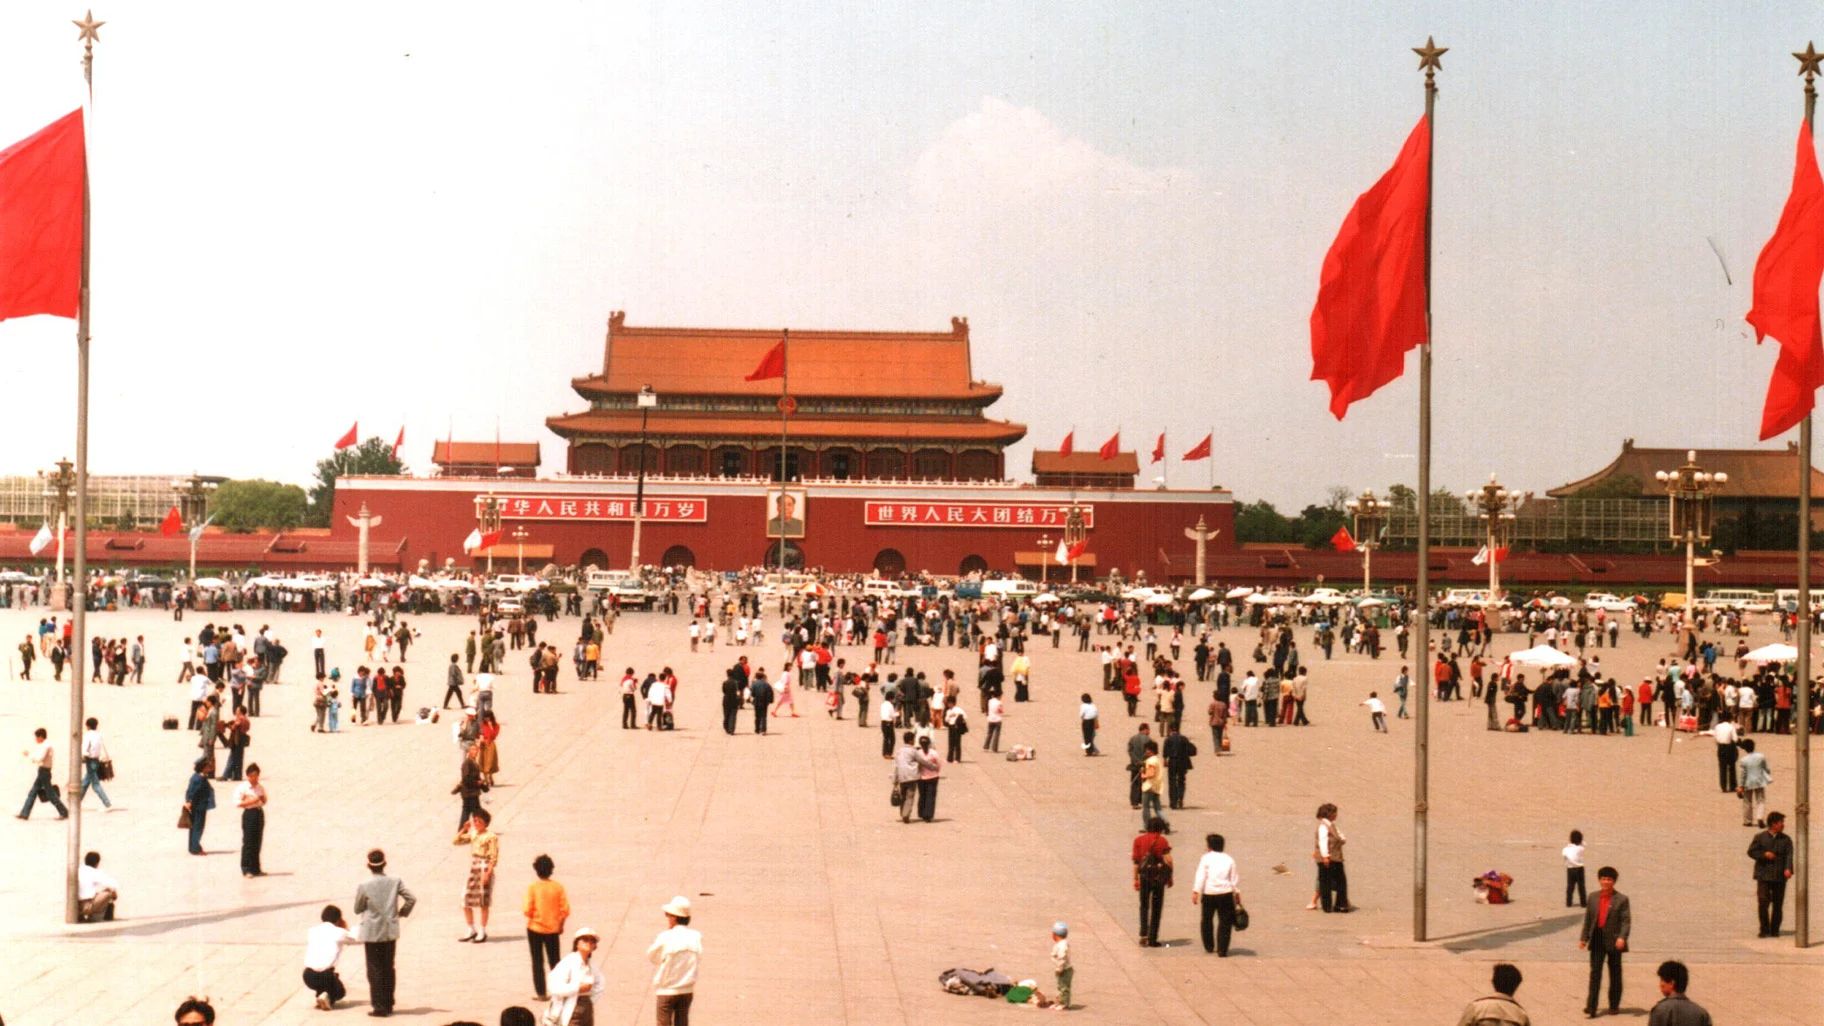Describe a typical morning in Tiananmen Square. A typical morning in Tiananmen Square begins with the gentle light of dawn casting a soft glow over the vast expanse. The square gradually comes to life as locals arrive for their morning exercises. Small groups practice tai chi, their synchronized movements creating a serene and graceful display. Joggers and walkers make their way across the square, occasionally pausing to admire the statues and the grandiose buildings. The morning flag-raising ceremony attracts visitors and spectators who gaze proudly at the Chinese flag ascending the pole against a backdrop of a clear, blue sky. Vendors begin setting up their stalls, preparing for the day's influx of tourists and locals seeking snacks and souvenirs. It's a harmonious blend of tranquility and anticipation, as the square prepares to greet another bustling day. 